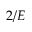Convert formula to latex. <formula><loc_0><loc_0><loc_500><loc_500>2 / E</formula> 